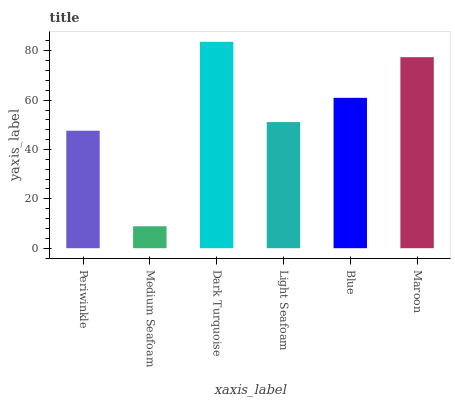Is Medium Seafoam the minimum?
Answer yes or no. Yes. Is Dark Turquoise the maximum?
Answer yes or no. Yes. Is Dark Turquoise the minimum?
Answer yes or no. No. Is Medium Seafoam the maximum?
Answer yes or no. No. Is Dark Turquoise greater than Medium Seafoam?
Answer yes or no. Yes. Is Medium Seafoam less than Dark Turquoise?
Answer yes or no. Yes. Is Medium Seafoam greater than Dark Turquoise?
Answer yes or no. No. Is Dark Turquoise less than Medium Seafoam?
Answer yes or no. No. Is Blue the high median?
Answer yes or no. Yes. Is Light Seafoam the low median?
Answer yes or no. Yes. Is Maroon the high median?
Answer yes or no. No. Is Dark Turquoise the low median?
Answer yes or no. No. 